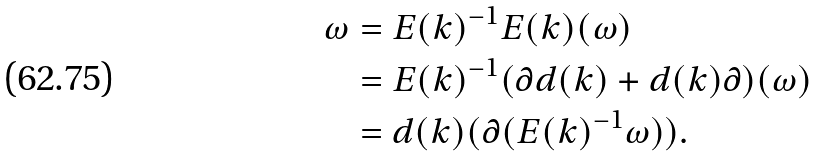Convert formula to latex. <formula><loc_0><loc_0><loc_500><loc_500>\omega & = E ( k ) ^ { - 1 } E ( k ) ( \omega ) \\ & = E ( k ) ^ { - 1 } ( \partial d ( k ) + d ( k ) \partial ) ( \omega ) \\ & = d ( k ) ( \partial ( E ( k ) ^ { - 1 } \omega ) ) . \\</formula> 